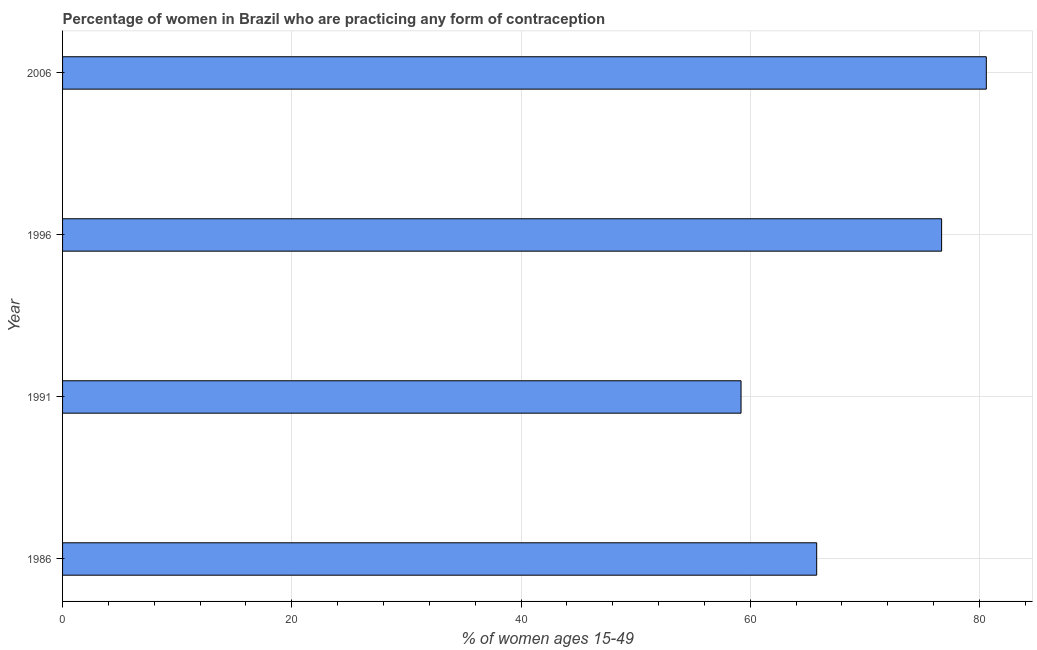What is the title of the graph?
Your response must be concise. Percentage of women in Brazil who are practicing any form of contraception. What is the label or title of the X-axis?
Offer a terse response. % of women ages 15-49. What is the label or title of the Y-axis?
Provide a succinct answer. Year. What is the contraceptive prevalence in 1996?
Offer a very short reply. 76.7. Across all years, what is the maximum contraceptive prevalence?
Provide a short and direct response. 80.6. Across all years, what is the minimum contraceptive prevalence?
Make the answer very short. 59.2. In which year was the contraceptive prevalence maximum?
Your response must be concise. 2006. What is the sum of the contraceptive prevalence?
Your answer should be very brief. 282.3. What is the difference between the contraceptive prevalence in 1986 and 1991?
Provide a succinct answer. 6.6. What is the average contraceptive prevalence per year?
Keep it short and to the point. 70.58. What is the median contraceptive prevalence?
Offer a very short reply. 71.25. In how many years, is the contraceptive prevalence greater than 60 %?
Offer a terse response. 3. What is the ratio of the contraceptive prevalence in 1991 to that in 2006?
Make the answer very short. 0.73. Is the contraceptive prevalence in 1996 less than that in 2006?
Your answer should be very brief. Yes. Is the difference between the contraceptive prevalence in 1986 and 2006 greater than the difference between any two years?
Offer a terse response. No. What is the difference between the highest and the lowest contraceptive prevalence?
Offer a very short reply. 21.4. In how many years, is the contraceptive prevalence greater than the average contraceptive prevalence taken over all years?
Keep it short and to the point. 2. How many bars are there?
Your response must be concise. 4. How many years are there in the graph?
Your answer should be compact. 4. What is the % of women ages 15-49 in 1986?
Make the answer very short. 65.8. What is the % of women ages 15-49 in 1991?
Provide a short and direct response. 59.2. What is the % of women ages 15-49 of 1996?
Ensure brevity in your answer.  76.7. What is the % of women ages 15-49 in 2006?
Your response must be concise. 80.6. What is the difference between the % of women ages 15-49 in 1986 and 1991?
Provide a short and direct response. 6.6. What is the difference between the % of women ages 15-49 in 1986 and 1996?
Provide a short and direct response. -10.9. What is the difference between the % of women ages 15-49 in 1986 and 2006?
Your response must be concise. -14.8. What is the difference between the % of women ages 15-49 in 1991 and 1996?
Keep it short and to the point. -17.5. What is the difference between the % of women ages 15-49 in 1991 and 2006?
Ensure brevity in your answer.  -21.4. What is the ratio of the % of women ages 15-49 in 1986 to that in 1991?
Offer a very short reply. 1.11. What is the ratio of the % of women ages 15-49 in 1986 to that in 1996?
Your answer should be compact. 0.86. What is the ratio of the % of women ages 15-49 in 1986 to that in 2006?
Ensure brevity in your answer.  0.82. What is the ratio of the % of women ages 15-49 in 1991 to that in 1996?
Provide a short and direct response. 0.77. What is the ratio of the % of women ages 15-49 in 1991 to that in 2006?
Make the answer very short. 0.73. 